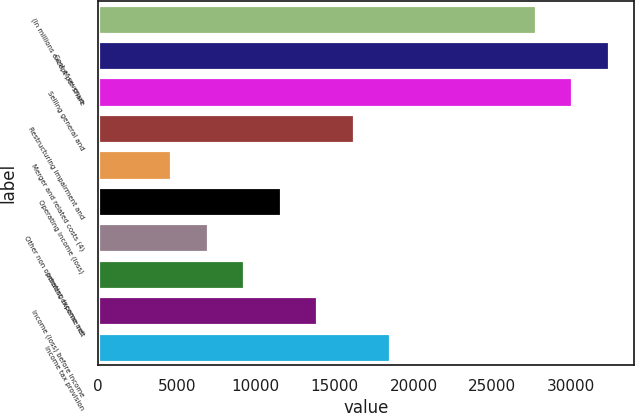<chart> <loc_0><loc_0><loc_500><loc_500><bar_chart><fcel>(In millions except per share<fcel>Cost of revenue<fcel>Selling general and<fcel>Restructuring impairment and<fcel>Merger and related costs (4)<fcel>Operating income (loss)<fcel>Other non operating income net<fcel>Interest expense net<fcel>Income (loss) before income<fcel>Income tax provision<nl><fcel>27757<fcel>32381<fcel>30069<fcel>16197<fcel>4637<fcel>11573<fcel>6949<fcel>9261<fcel>13885<fcel>18509<nl></chart> 